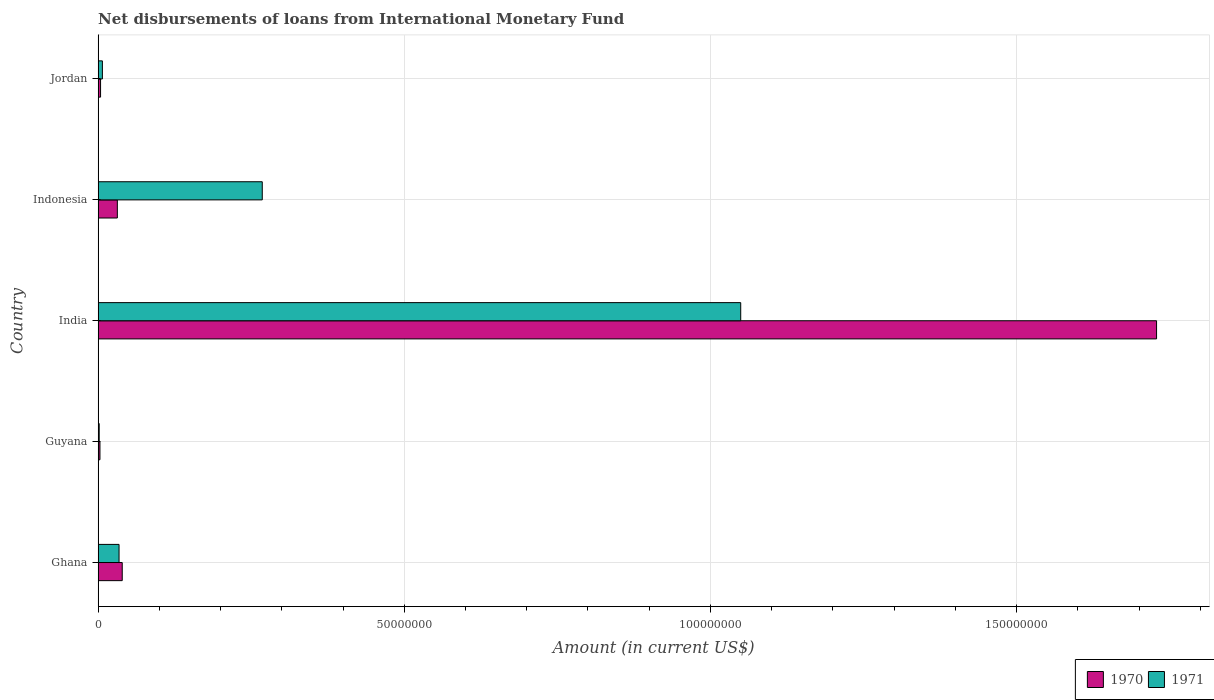How many different coloured bars are there?
Provide a succinct answer. 2. Are the number of bars per tick equal to the number of legend labels?
Provide a short and direct response. Yes. How many bars are there on the 1st tick from the top?
Make the answer very short. 2. In how many cases, is the number of bars for a given country not equal to the number of legend labels?
Your answer should be compact. 0. What is the amount of loans disbursed in 1970 in Indonesia?
Give a very brief answer. 3.14e+06. Across all countries, what is the maximum amount of loans disbursed in 1970?
Keep it short and to the point. 1.73e+08. Across all countries, what is the minimum amount of loans disbursed in 1971?
Provide a short and direct response. 1.76e+05. In which country was the amount of loans disbursed in 1970 maximum?
Your response must be concise. India. In which country was the amount of loans disbursed in 1971 minimum?
Your answer should be very brief. Guyana. What is the total amount of loans disbursed in 1970 in the graph?
Make the answer very short. 1.81e+08. What is the difference between the amount of loans disbursed in 1970 in Indonesia and that in Jordan?
Your answer should be compact. 2.74e+06. What is the difference between the amount of loans disbursed in 1971 in Jordan and the amount of loans disbursed in 1970 in Ghana?
Offer a very short reply. -3.24e+06. What is the average amount of loans disbursed in 1971 per country?
Keep it short and to the point. 2.72e+07. What is the difference between the amount of loans disbursed in 1970 and amount of loans disbursed in 1971 in India?
Provide a succinct answer. 6.79e+07. In how many countries, is the amount of loans disbursed in 1971 greater than 50000000 US$?
Make the answer very short. 1. What is the ratio of the amount of loans disbursed in 1971 in India to that in Indonesia?
Keep it short and to the point. 3.91. What is the difference between the highest and the second highest amount of loans disbursed in 1971?
Your answer should be very brief. 7.81e+07. What is the difference between the highest and the lowest amount of loans disbursed in 1970?
Keep it short and to the point. 1.73e+08. In how many countries, is the amount of loans disbursed in 1970 greater than the average amount of loans disbursed in 1970 taken over all countries?
Your answer should be very brief. 1. What does the 1st bar from the bottom in Jordan represents?
Offer a terse response. 1970. How many countries are there in the graph?
Make the answer very short. 5. What is the difference between two consecutive major ticks on the X-axis?
Provide a short and direct response. 5.00e+07. Are the values on the major ticks of X-axis written in scientific E-notation?
Offer a very short reply. No. Does the graph contain grids?
Ensure brevity in your answer.  Yes. Where does the legend appear in the graph?
Your answer should be compact. Bottom right. How many legend labels are there?
Ensure brevity in your answer.  2. How are the legend labels stacked?
Ensure brevity in your answer.  Horizontal. What is the title of the graph?
Provide a short and direct response. Net disbursements of loans from International Monetary Fund. What is the label or title of the Y-axis?
Give a very brief answer. Country. What is the Amount (in current US$) of 1970 in Ghana?
Your response must be concise. 3.94e+06. What is the Amount (in current US$) in 1971 in Ghana?
Ensure brevity in your answer.  3.42e+06. What is the Amount (in current US$) in 1970 in Guyana?
Give a very brief answer. 2.99e+05. What is the Amount (in current US$) in 1971 in Guyana?
Provide a short and direct response. 1.76e+05. What is the Amount (in current US$) of 1970 in India?
Your answer should be very brief. 1.73e+08. What is the Amount (in current US$) of 1971 in India?
Provide a succinct answer. 1.05e+08. What is the Amount (in current US$) in 1970 in Indonesia?
Your answer should be compact. 3.14e+06. What is the Amount (in current US$) of 1971 in Indonesia?
Your answer should be compact. 2.68e+07. What is the Amount (in current US$) of 1970 in Jordan?
Provide a short and direct response. 3.99e+05. What is the Amount (in current US$) in 1971 in Jordan?
Your answer should be compact. 6.99e+05. Across all countries, what is the maximum Amount (in current US$) of 1970?
Give a very brief answer. 1.73e+08. Across all countries, what is the maximum Amount (in current US$) of 1971?
Make the answer very short. 1.05e+08. Across all countries, what is the minimum Amount (in current US$) in 1970?
Provide a succinct answer. 2.99e+05. Across all countries, what is the minimum Amount (in current US$) of 1971?
Provide a short and direct response. 1.76e+05. What is the total Amount (in current US$) in 1970 in the graph?
Your response must be concise. 1.81e+08. What is the total Amount (in current US$) of 1971 in the graph?
Your response must be concise. 1.36e+08. What is the difference between the Amount (in current US$) in 1970 in Ghana and that in Guyana?
Ensure brevity in your answer.  3.64e+06. What is the difference between the Amount (in current US$) of 1971 in Ghana and that in Guyana?
Provide a succinct answer. 3.24e+06. What is the difference between the Amount (in current US$) of 1970 in Ghana and that in India?
Your answer should be very brief. -1.69e+08. What is the difference between the Amount (in current US$) in 1971 in Ghana and that in India?
Ensure brevity in your answer.  -1.02e+08. What is the difference between the Amount (in current US$) in 1970 in Ghana and that in Indonesia?
Provide a succinct answer. 7.99e+05. What is the difference between the Amount (in current US$) of 1971 in Ghana and that in Indonesia?
Provide a short and direct response. -2.34e+07. What is the difference between the Amount (in current US$) of 1970 in Ghana and that in Jordan?
Your answer should be very brief. 3.54e+06. What is the difference between the Amount (in current US$) of 1971 in Ghana and that in Jordan?
Provide a succinct answer. 2.72e+06. What is the difference between the Amount (in current US$) of 1970 in Guyana and that in India?
Provide a succinct answer. -1.73e+08. What is the difference between the Amount (in current US$) in 1971 in Guyana and that in India?
Your response must be concise. -1.05e+08. What is the difference between the Amount (in current US$) of 1970 in Guyana and that in Indonesia?
Your response must be concise. -2.84e+06. What is the difference between the Amount (in current US$) in 1971 in Guyana and that in Indonesia?
Your answer should be very brief. -2.66e+07. What is the difference between the Amount (in current US$) of 1970 in Guyana and that in Jordan?
Your answer should be compact. -1.00e+05. What is the difference between the Amount (in current US$) of 1971 in Guyana and that in Jordan?
Give a very brief answer. -5.23e+05. What is the difference between the Amount (in current US$) of 1970 in India and that in Indonesia?
Keep it short and to the point. 1.70e+08. What is the difference between the Amount (in current US$) in 1971 in India and that in Indonesia?
Your response must be concise. 7.81e+07. What is the difference between the Amount (in current US$) of 1970 in India and that in Jordan?
Offer a very short reply. 1.72e+08. What is the difference between the Amount (in current US$) in 1971 in India and that in Jordan?
Provide a succinct answer. 1.04e+08. What is the difference between the Amount (in current US$) in 1970 in Indonesia and that in Jordan?
Your answer should be compact. 2.74e+06. What is the difference between the Amount (in current US$) in 1971 in Indonesia and that in Jordan?
Your answer should be very brief. 2.61e+07. What is the difference between the Amount (in current US$) of 1970 in Ghana and the Amount (in current US$) of 1971 in Guyana?
Your answer should be very brief. 3.76e+06. What is the difference between the Amount (in current US$) in 1970 in Ghana and the Amount (in current US$) in 1971 in India?
Give a very brief answer. -1.01e+08. What is the difference between the Amount (in current US$) in 1970 in Ghana and the Amount (in current US$) in 1971 in Indonesia?
Your response must be concise. -2.29e+07. What is the difference between the Amount (in current US$) in 1970 in Ghana and the Amount (in current US$) in 1971 in Jordan?
Offer a very short reply. 3.24e+06. What is the difference between the Amount (in current US$) in 1970 in Guyana and the Amount (in current US$) in 1971 in India?
Provide a short and direct response. -1.05e+08. What is the difference between the Amount (in current US$) in 1970 in Guyana and the Amount (in current US$) in 1971 in Indonesia?
Make the answer very short. -2.65e+07. What is the difference between the Amount (in current US$) in 1970 in Guyana and the Amount (in current US$) in 1971 in Jordan?
Ensure brevity in your answer.  -4.00e+05. What is the difference between the Amount (in current US$) of 1970 in India and the Amount (in current US$) of 1971 in Indonesia?
Keep it short and to the point. 1.46e+08. What is the difference between the Amount (in current US$) in 1970 in India and the Amount (in current US$) in 1971 in Jordan?
Provide a short and direct response. 1.72e+08. What is the difference between the Amount (in current US$) of 1970 in Indonesia and the Amount (in current US$) of 1971 in Jordan?
Make the answer very short. 2.44e+06. What is the average Amount (in current US$) in 1970 per country?
Make the answer very short. 3.61e+07. What is the average Amount (in current US$) in 1971 per country?
Your answer should be compact. 2.72e+07. What is the difference between the Amount (in current US$) of 1970 and Amount (in current US$) of 1971 in Ghana?
Provide a succinct answer. 5.20e+05. What is the difference between the Amount (in current US$) of 1970 and Amount (in current US$) of 1971 in Guyana?
Offer a very short reply. 1.23e+05. What is the difference between the Amount (in current US$) in 1970 and Amount (in current US$) in 1971 in India?
Your response must be concise. 6.79e+07. What is the difference between the Amount (in current US$) of 1970 and Amount (in current US$) of 1971 in Indonesia?
Provide a short and direct response. -2.37e+07. What is the difference between the Amount (in current US$) of 1970 and Amount (in current US$) of 1971 in Jordan?
Your answer should be compact. -3.00e+05. What is the ratio of the Amount (in current US$) of 1970 in Ghana to that in Guyana?
Your answer should be very brief. 13.17. What is the ratio of the Amount (in current US$) in 1971 in Ghana to that in Guyana?
Offer a very short reply. 19.42. What is the ratio of the Amount (in current US$) of 1970 in Ghana to that in India?
Offer a very short reply. 0.02. What is the ratio of the Amount (in current US$) of 1971 in Ghana to that in India?
Make the answer very short. 0.03. What is the ratio of the Amount (in current US$) in 1970 in Ghana to that in Indonesia?
Ensure brevity in your answer.  1.25. What is the ratio of the Amount (in current US$) in 1971 in Ghana to that in Indonesia?
Your response must be concise. 0.13. What is the ratio of the Amount (in current US$) in 1970 in Ghana to that in Jordan?
Your answer should be compact. 9.87. What is the ratio of the Amount (in current US$) of 1971 in Ghana to that in Jordan?
Provide a short and direct response. 4.89. What is the ratio of the Amount (in current US$) in 1970 in Guyana to that in India?
Provide a short and direct response. 0. What is the ratio of the Amount (in current US$) of 1971 in Guyana to that in India?
Give a very brief answer. 0. What is the ratio of the Amount (in current US$) of 1970 in Guyana to that in Indonesia?
Your answer should be very brief. 0.1. What is the ratio of the Amount (in current US$) in 1971 in Guyana to that in Indonesia?
Provide a succinct answer. 0.01. What is the ratio of the Amount (in current US$) of 1970 in Guyana to that in Jordan?
Provide a succinct answer. 0.75. What is the ratio of the Amount (in current US$) of 1971 in Guyana to that in Jordan?
Offer a very short reply. 0.25. What is the ratio of the Amount (in current US$) of 1970 in India to that in Indonesia?
Offer a terse response. 55.07. What is the ratio of the Amount (in current US$) of 1971 in India to that in Indonesia?
Make the answer very short. 3.91. What is the ratio of the Amount (in current US$) of 1970 in India to that in Jordan?
Keep it short and to the point. 433.25. What is the ratio of the Amount (in current US$) in 1971 in India to that in Jordan?
Ensure brevity in your answer.  150.14. What is the ratio of the Amount (in current US$) in 1970 in Indonesia to that in Jordan?
Keep it short and to the point. 7.87. What is the ratio of the Amount (in current US$) of 1971 in Indonesia to that in Jordan?
Your answer should be very brief. 38.35. What is the difference between the highest and the second highest Amount (in current US$) in 1970?
Your response must be concise. 1.69e+08. What is the difference between the highest and the second highest Amount (in current US$) of 1971?
Offer a very short reply. 7.81e+07. What is the difference between the highest and the lowest Amount (in current US$) in 1970?
Provide a short and direct response. 1.73e+08. What is the difference between the highest and the lowest Amount (in current US$) in 1971?
Your answer should be very brief. 1.05e+08. 